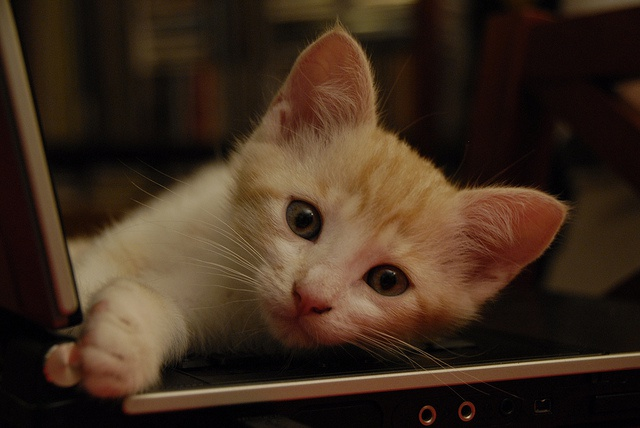Describe the objects in this image and their specific colors. I can see cat in black, gray, and maroon tones and laptop in black, maroon, and tan tones in this image. 